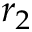Convert formula to latex. <formula><loc_0><loc_0><loc_500><loc_500>r _ { 2 }</formula> 